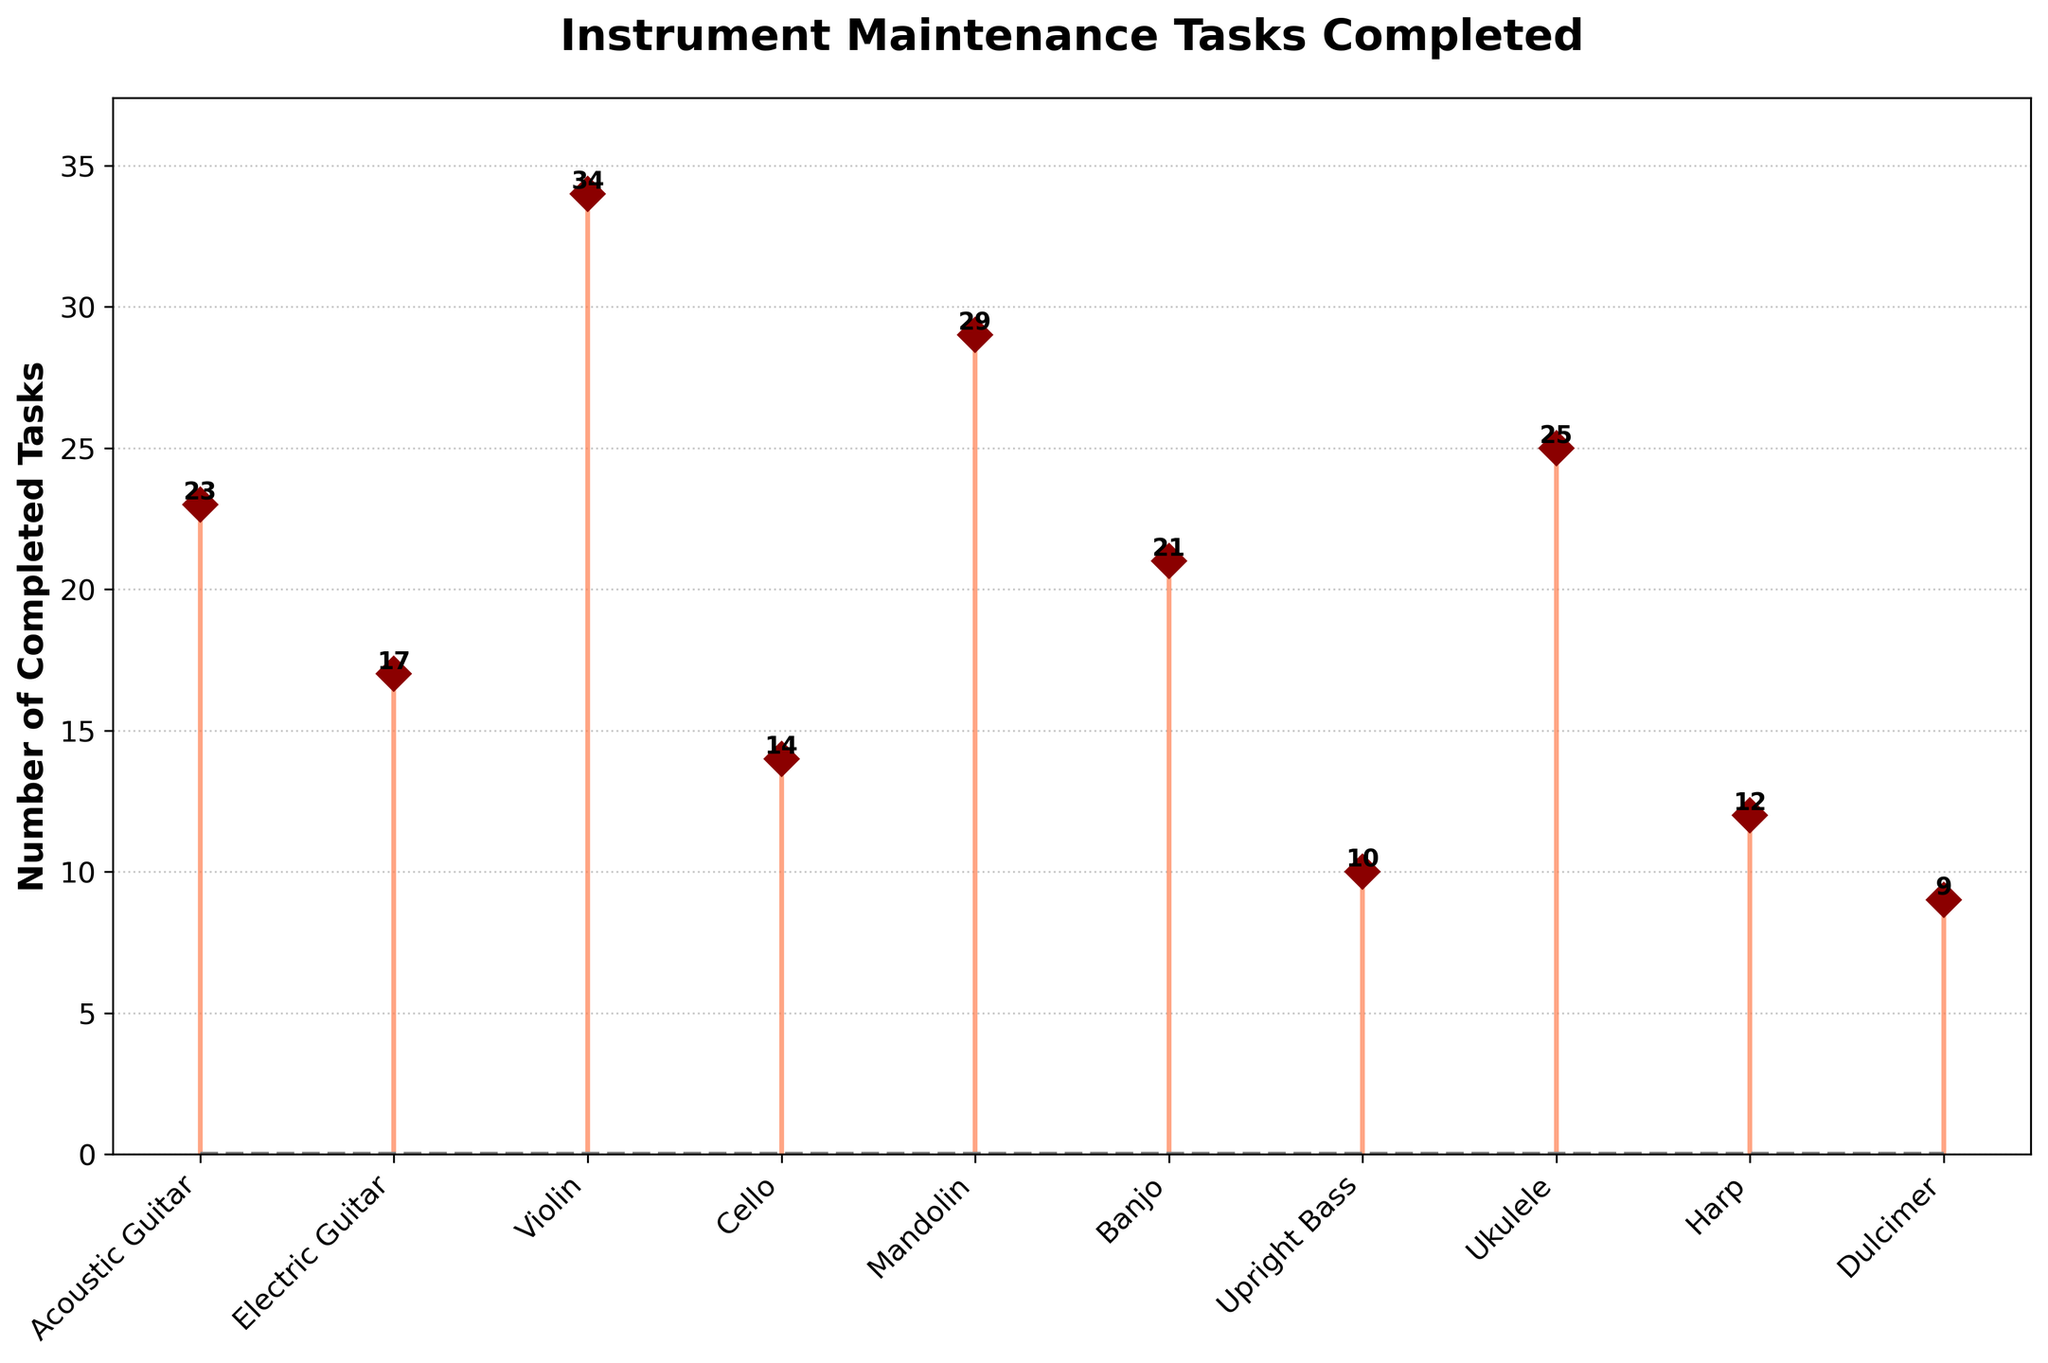Which instrument has the highest number of completed maintenance tasks? Check the y-values and find the highest data point. The Violin has the highest stem, which reaches 34 tasks.
Answer: Violin How many maintenance tasks were completed for Banjo and Mandolin combined? Find the y-values for Banjo and Mandolin (21 and 29, respectively) and sum them up. 21 + 29 = 50.
Answer: 50 Which instrument has fewer completed tasks, Ukulele or Harp? Compare the heights of the stems for Ukulele and Harp. Ukulele has 25 tasks, and Harp has 12 tasks.
Answer: Harp What's the range of the number of maintenance tasks completed? Identify the maximum and minimum y-values. The highest is 34 (Violin), and the lowest is 9 (Dulcimer). Subtract the minimum from the maximum: 34 - 9 = 25.
Answer: 25 What is the median number of maintenance tasks completed across all instrument types? List all completed tasks (9, 10, 12, 14, 17, 21, 23, 25, 29, 34) and find the middle value(s). For 10 values, the median is the average of the 5th and 6th values: (17 + 21) / 2 = 19.
Answer: 19 List the instruments with more than 20 maintenance tasks completed. Examine the y-values and list instruments where the value is greater than 20: Acoustic Guitar (23), Mandolin (29), Ukulele (25), Violin (34), Banjo (21).
Answer: Acoustic Guitar, Mandolin, Ukulele, Violin, Banjo By how much does the number of completed tasks for Cello fall short of the number for Violin? Subtract the y-values of Cello and Violin. Violin has 34 tasks, and Cello has 14. 34 - 14 = 20.
Answer: 20 Which instrument's maintenance tasks are closest to the average number of completed tasks across all instruments? (Intermediate calculations required) First, find the average number of tasks: (23 + 17 + 34 + 14 + 29 + 21 + 10 + 25 + 12 + 9) / 10 = 19.4. Then, observe the instruments' tasks: Cello (14), which is closest to 19.4.
Answer: Cello What is the total number of maintenance tasks completed for string instruments (Acoustic Guitar, Electric Guitar, Violin, Cello, Upright Bass)? Sum the completed tasks for these instruments. (23 + 17 + 34 + 14 + 10) = 98.
Answer: 98 Which instrument witnessed the least number of maintenance tasks? Identify the smallest y-value on the plot. The Dulcimer has the smallest value with 9 tasks.
Answer: Dulcimer 